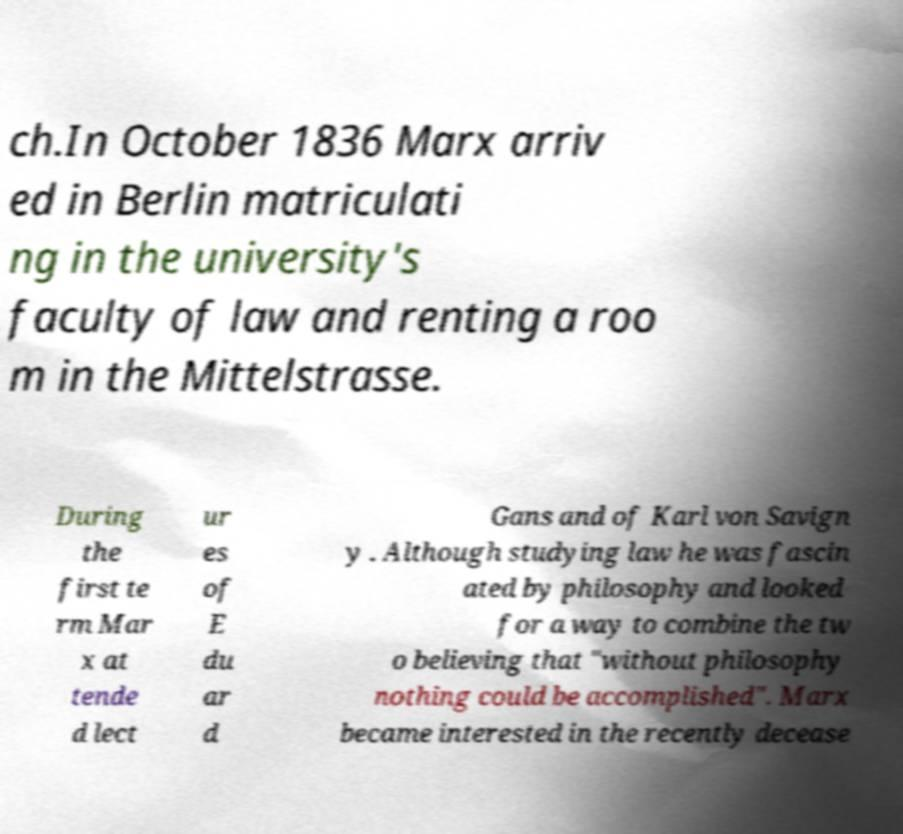For documentation purposes, I need the text within this image transcribed. Could you provide that? ch.In October 1836 Marx arriv ed in Berlin matriculati ng in the university's faculty of law and renting a roo m in the Mittelstrasse. During the first te rm Mar x at tende d lect ur es of E du ar d Gans and of Karl von Savign y . Although studying law he was fascin ated by philosophy and looked for a way to combine the tw o believing that "without philosophy nothing could be accomplished". Marx became interested in the recently decease 